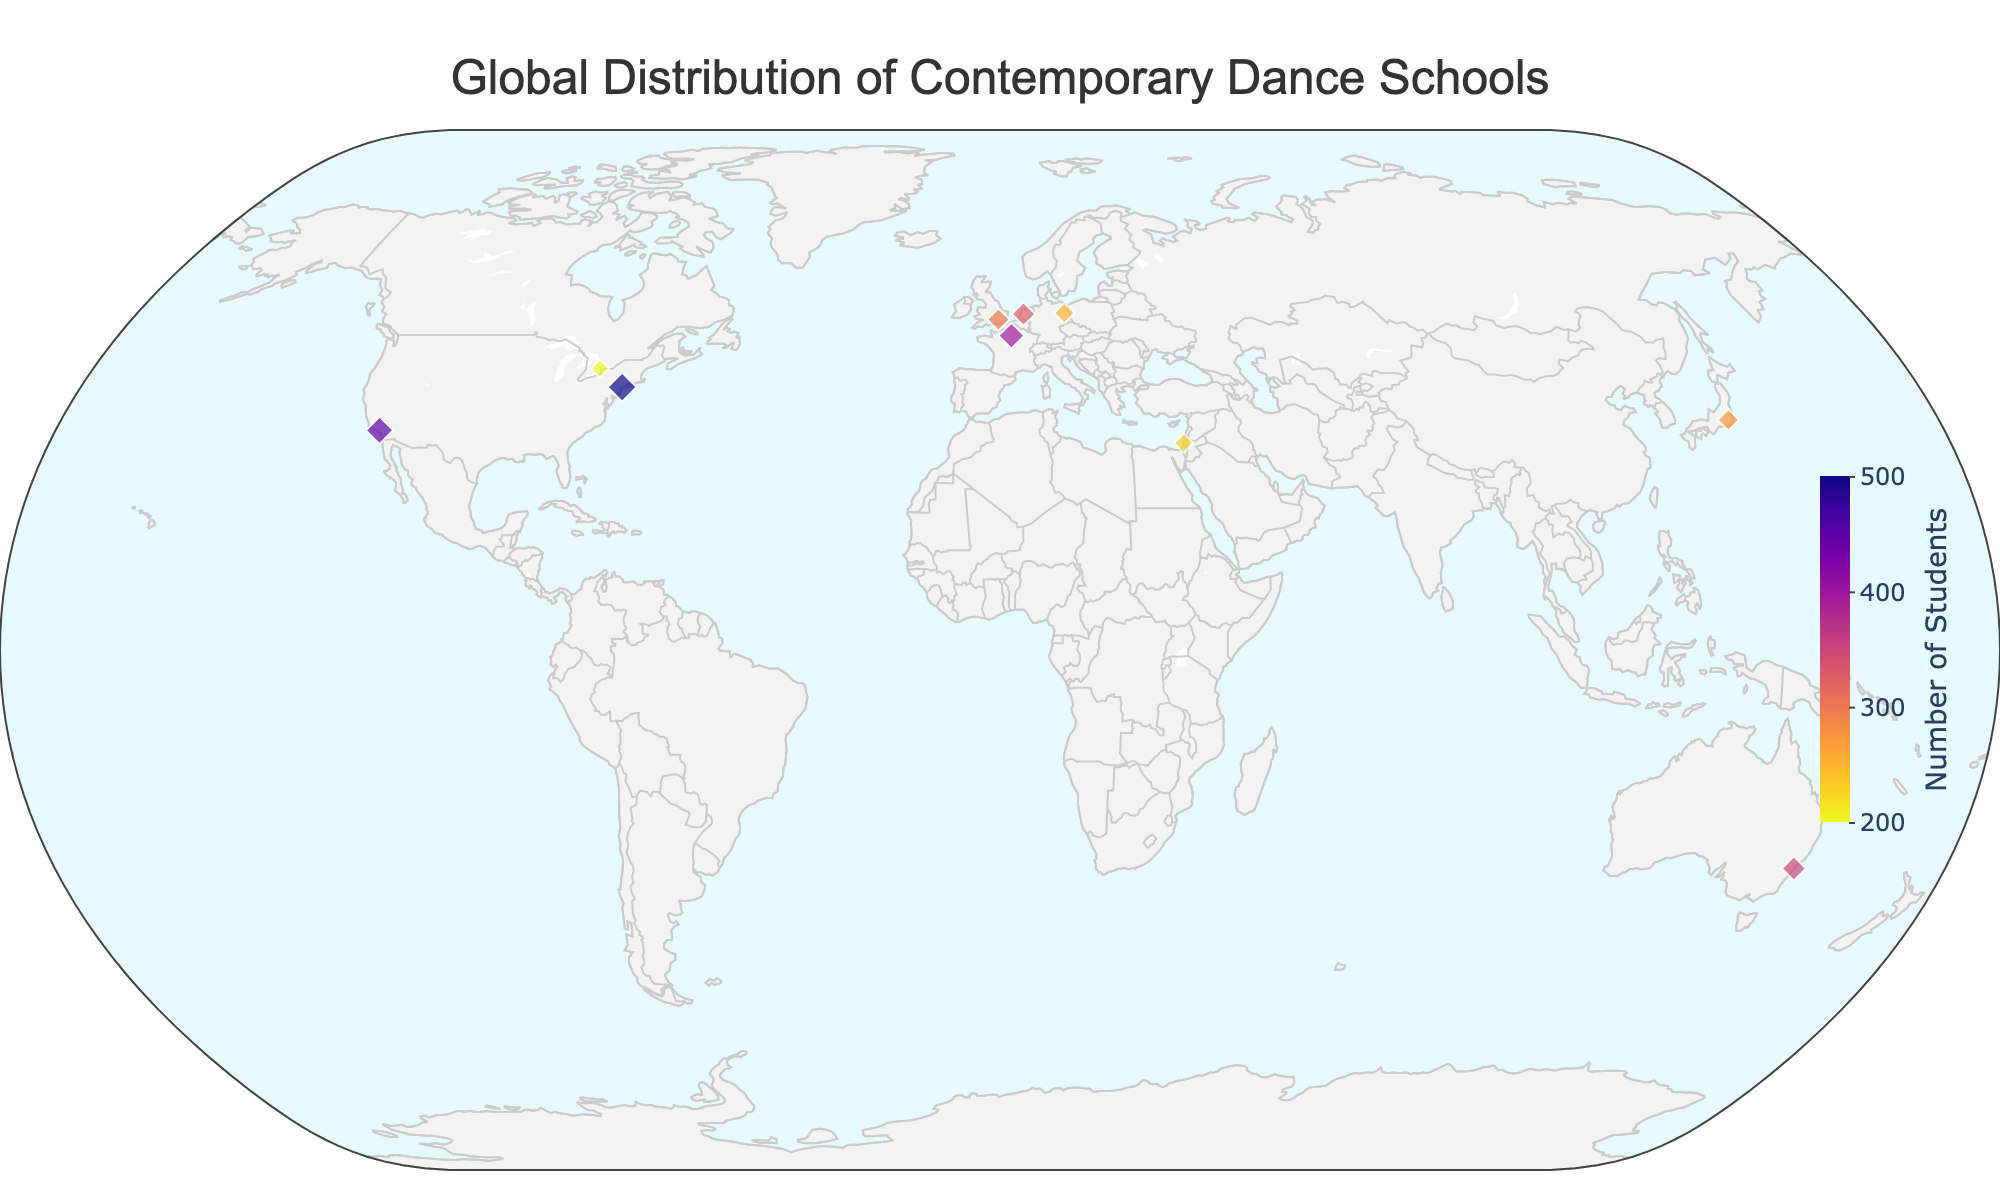What is the title of the figure? The title of the figure is a prominent text at the top center that describes the main topic being visualized. In this case, it reads "Global Distribution of Contemporary Dance Schools."
Answer: Global Distribution of Contemporary Dance Schools How many dance schools are depicted in New York and Los Angeles combined? First, identify the dance schools in New York (Juilliard School) and Los Angeles (Edge Performing Arts Center) on the plot. Each city has one school, so the total is 1 + 1.
Answer: 2 Which school has the largest number of students? Look for the marker with the largest size as the marker size correlates with the number of students, and check the color which denotes a higher value. The tooltip shows "Juilliard School" with 500 students.
Answer: Juilliard School Which city in the USA has a higher number of students: New York or Los Angeles? Compare the marker sizes and colors for Juilliard School in New York and Edge Performing Arts Center in Los Angeles. From the data provided in the tooltip, New York's Juilliard School has 500 students, while Los Angeles' Edge Performing Arts Center has 450 students.
Answer: New York What is the average number of students across all dance schools in Europe (UK, France, Germany, Netherlands)? Identify the number of students for the dance schools in London (300), Paris (400), Berlin (250), and Amsterdam (325). Calculate the average: (300 + 400 + 250 + 325) / 4 = 1275 / 4 = 318.75.
Answer: 318.75 Which continent has the most dance schools represented on the plot? Count the number of dance schools in each continent: North America (3: New York, Los Angeles, Toronto), Europe (4: London, Paris, Berlin, Amsterdam), Asia (2: Tokyo, Tel Aviv), Oceania (1: Sydney). Europe has the most with 4 schools.
Answer: Europe Which city has the smallest dance school by the number of students? Look for the marker with the smallest size and darkest color, and hover over it to read the tooltip. The "School of Toronto Dance Theatre" in Toronto has the smallest with 200 students.
Answer: Toronto What is the sum of students in the schools located in the USA? Sum the number of students in Juilliard School (500) and Edge Performing Arts Center (450). The total is 500 + 450.
Answer: 950 Among the dance schools in cities by the sea (Sydney, Tel Aviv), which has a larger number of students? Compare the marker sizes and colors for the schools in Sydney (350) and Tel Aviv (225). Sydney Dance Company has more students.
Answer: Sydney How many dance schools are there in Asia? Count the markers in Asia: Tokyo (Setsuko Yamada Dance Institute) and Tel Aviv (Batsheva Dance Company School). There are 2 dance schools.
Answer: 2 